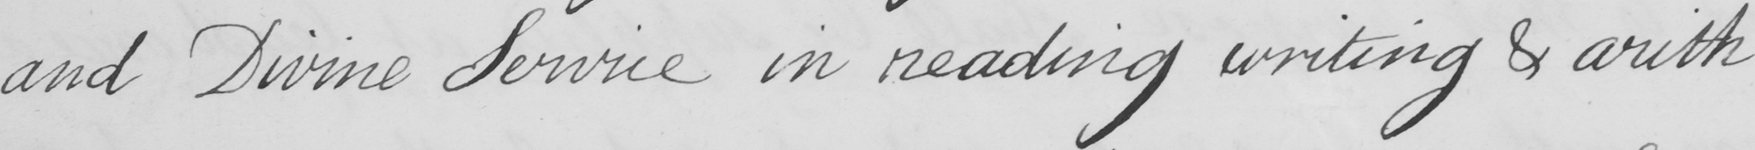Please provide the text content of this handwritten line. and Divine Service in reading writing & arith- 